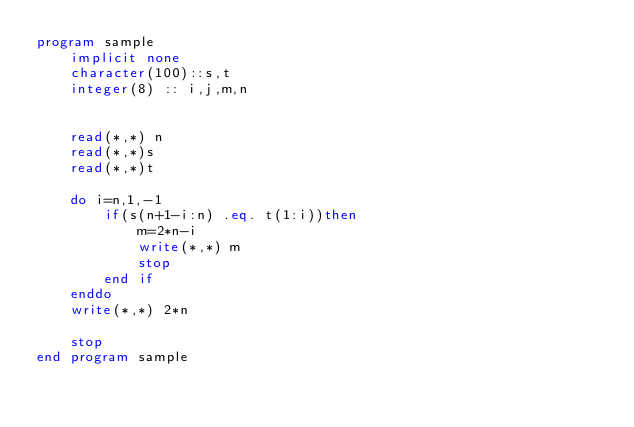Convert code to text. <code><loc_0><loc_0><loc_500><loc_500><_FORTRAN_>program sample
    implicit none
    character(100)::s,t
    integer(8) :: i,j,m,n
    
  
    read(*,*) n
    read(*,*)s
    read(*,*)t
    
    do i=n,1,-1
        if(s(n+1-i:n) .eq. t(1:i))then
            m=2*n-i
            write(*,*) m
            stop
        end if
    enddo
    write(*,*) 2*n
  
    stop
end program sample
  

</code> 